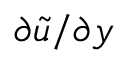<formula> <loc_0><loc_0><loc_500><loc_500>\partial \tilde { u } / \partial y</formula> 